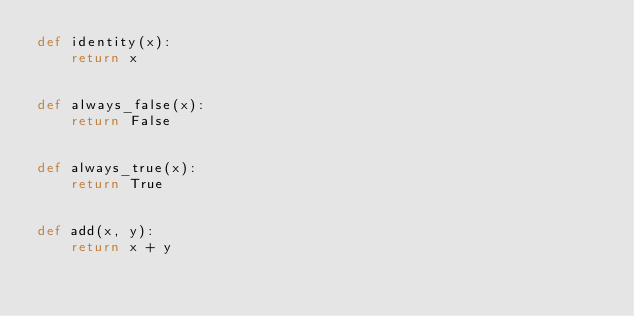<code> <loc_0><loc_0><loc_500><loc_500><_Python_>def identity(x):
    return x


def always_false(x):
    return False


def always_true(x):
    return True


def add(x, y):
    return x + y
</code> 